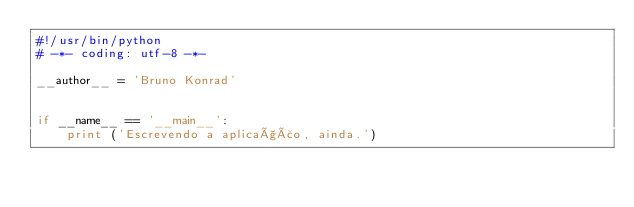Convert code to text. <code><loc_0><loc_0><loc_500><loc_500><_Python_>#!/usr/bin/python
# -*- coding: utf-8 -*-

__author__ = 'Bruno Konrad'


if __name__ == '__main__':
    print ('Escrevendo a aplicação, ainda.')</code> 